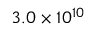Convert formula to latex. <formula><loc_0><loc_0><loc_500><loc_500>3 . 0 \times 1 0 ^ { 1 0 }</formula> 